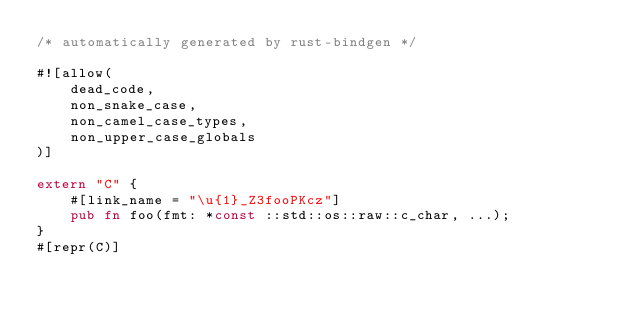<code> <loc_0><loc_0><loc_500><loc_500><_Rust_>/* automatically generated by rust-bindgen */

#![allow(
    dead_code,
    non_snake_case,
    non_camel_case_types,
    non_upper_case_globals
)]

extern "C" {
    #[link_name = "\u{1}_Z3fooPKcz"]
    pub fn foo(fmt: *const ::std::os::raw::c_char, ...);
}
#[repr(C)]</code> 